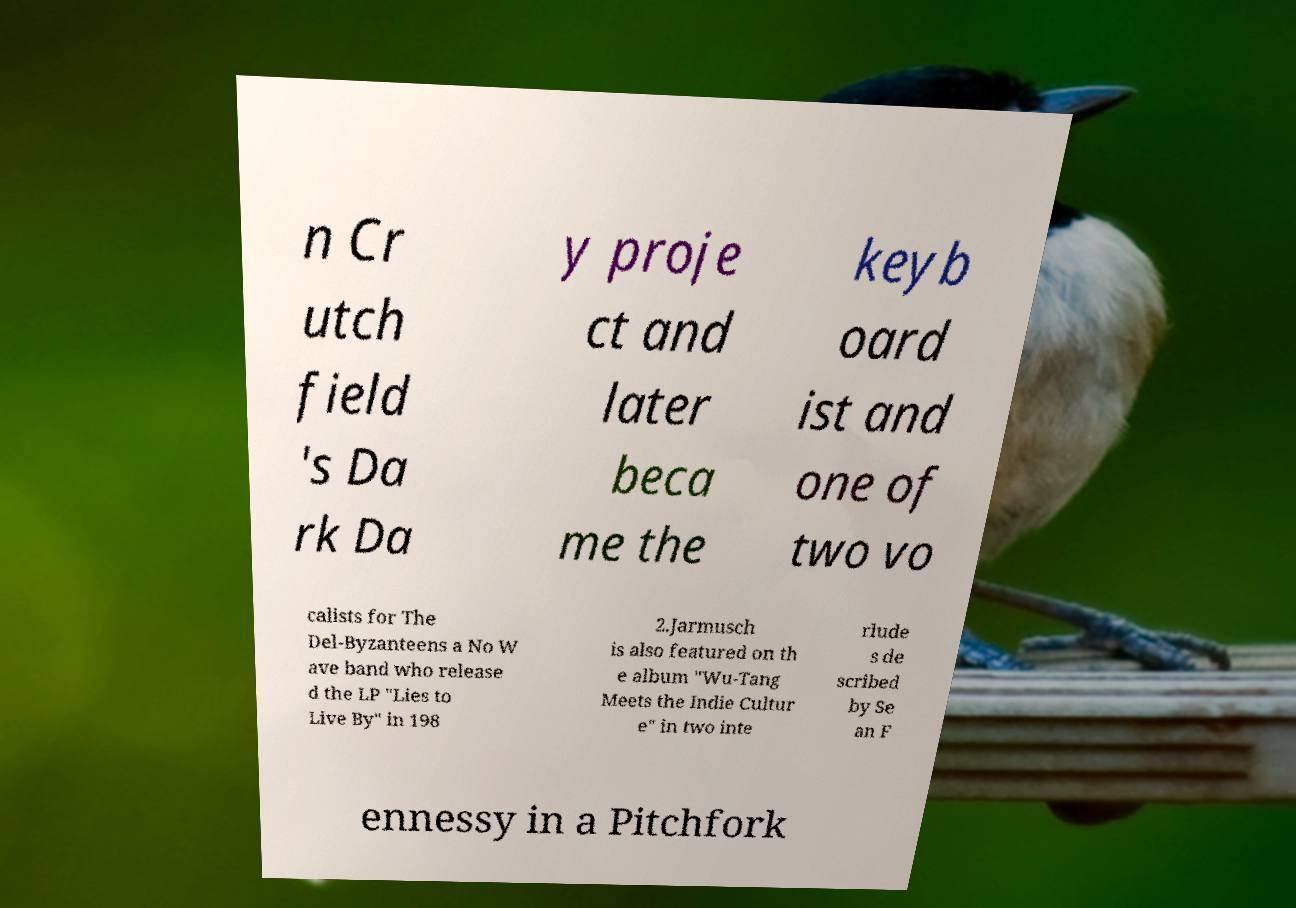I need the written content from this picture converted into text. Can you do that? n Cr utch field 's Da rk Da y proje ct and later beca me the keyb oard ist and one of two vo calists for The Del-Byzanteens a No W ave band who release d the LP "Lies to Live By" in 198 2.Jarmusch is also featured on th e album "Wu-Tang Meets the Indie Cultur e" in two inte rlude s de scribed by Se an F ennessy in a Pitchfork 